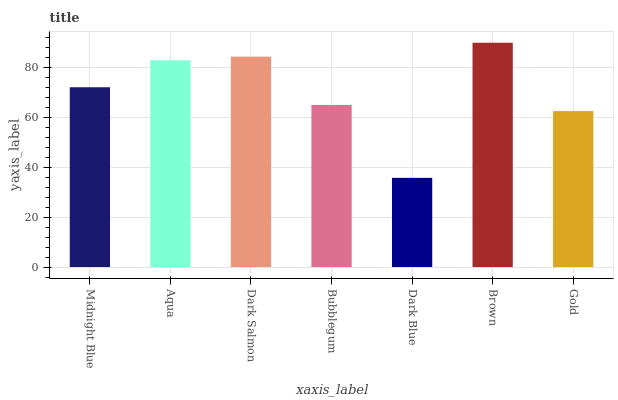Is Dark Blue the minimum?
Answer yes or no. Yes. Is Brown the maximum?
Answer yes or no. Yes. Is Aqua the minimum?
Answer yes or no. No. Is Aqua the maximum?
Answer yes or no. No. Is Aqua greater than Midnight Blue?
Answer yes or no. Yes. Is Midnight Blue less than Aqua?
Answer yes or no. Yes. Is Midnight Blue greater than Aqua?
Answer yes or no. No. Is Aqua less than Midnight Blue?
Answer yes or no. No. Is Midnight Blue the high median?
Answer yes or no. Yes. Is Midnight Blue the low median?
Answer yes or no. Yes. Is Bubblegum the high median?
Answer yes or no. No. Is Aqua the low median?
Answer yes or no. No. 